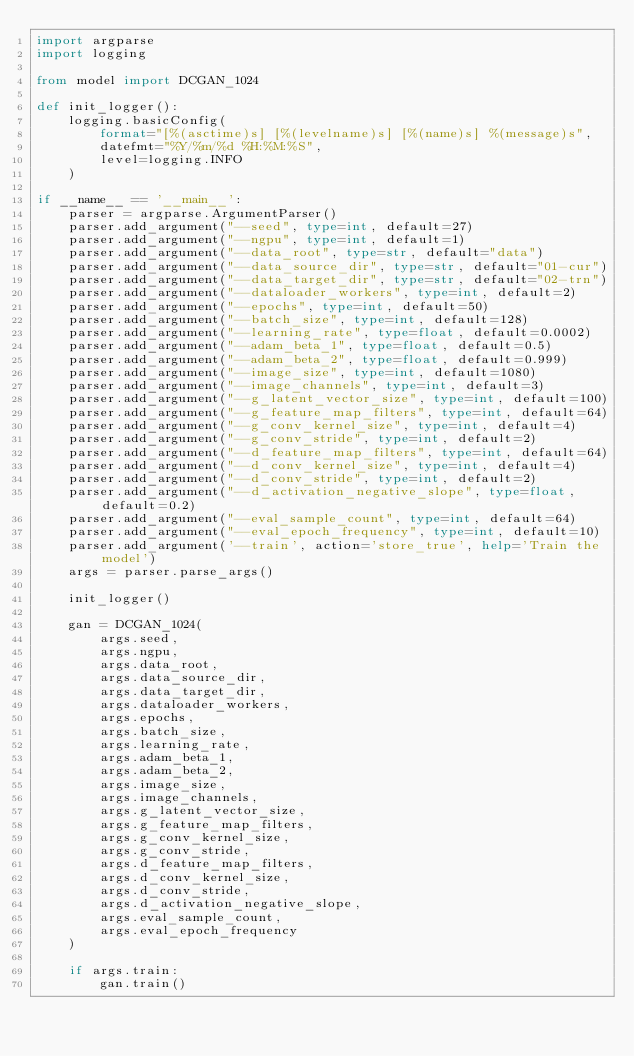Convert code to text. <code><loc_0><loc_0><loc_500><loc_500><_Python_>import argparse
import logging

from model import DCGAN_1024

def init_logger():
    logging.basicConfig(
        format="[%(asctime)s] [%(levelname)s] [%(name)s] %(message)s",
        datefmt="%Y/%m/%d %H:%M:%S",
        level=logging.INFO
    )

if __name__ == '__main__':
    parser = argparse.ArgumentParser()
    parser.add_argument("--seed", type=int, default=27)
    parser.add_argument("--ngpu", type=int, default=1)
    parser.add_argument("--data_root", type=str, default="data")
    parser.add_argument("--data_source_dir", type=str, default="01-cur")
    parser.add_argument("--data_target_dir", type=str, default="02-trn")
    parser.add_argument("--dataloader_workers", type=int, default=2)
    parser.add_argument("--epochs", type=int, default=50)
    parser.add_argument("--batch_size", type=int, default=128)
    parser.add_argument("--learning_rate", type=float, default=0.0002)
    parser.add_argument("--adam_beta_1", type=float, default=0.5)
    parser.add_argument("--adam_beta_2", type=float, default=0.999)
    parser.add_argument("--image_size", type=int, default=1080)
    parser.add_argument("--image_channels", type=int, default=3)
    parser.add_argument("--g_latent_vector_size", type=int, default=100)
    parser.add_argument("--g_feature_map_filters", type=int, default=64)
    parser.add_argument("--g_conv_kernel_size", type=int, default=4)
    parser.add_argument("--g_conv_stride", type=int, default=2)
    parser.add_argument("--d_feature_map_filters", type=int, default=64)
    parser.add_argument("--d_conv_kernel_size", type=int, default=4)
    parser.add_argument("--d_conv_stride", type=int, default=2)
    parser.add_argument("--d_activation_negative_slope", type=float, default=0.2)
    parser.add_argument("--eval_sample_count", type=int, default=64)
    parser.add_argument("--eval_epoch_frequency", type=int, default=10)
    parser.add_argument('--train', action='store_true', help='Train the model')
    args = parser.parse_args()

    init_logger()

    gan = DCGAN_1024(
        args.seed,
        args.ngpu,
        args.data_root,
        args.data_source_dir,
        args.data_target_dir,
        args.dataloader_workers,
        args.epochs,
        args.batch_size,
        args.learning_rate,
        args.adam_beta_1,
        args.adam_beta_2,
        args.image_size,
        args.image_channels,
        args.g_latent_vector_size,
        args.g_feature_map_filters,
        args.g_conv_kernel_size,
        args.g_conv_stride,
        args.d_feature_map_filters,
        args.d_conv_kernel_size,
        args.d_conv_stride,
        args.d_activation_negative_slope,
        args.eval_sample_count,
        args.eval_epoch_frequency
    )

    if args.train:
        gan.train()
</code> 